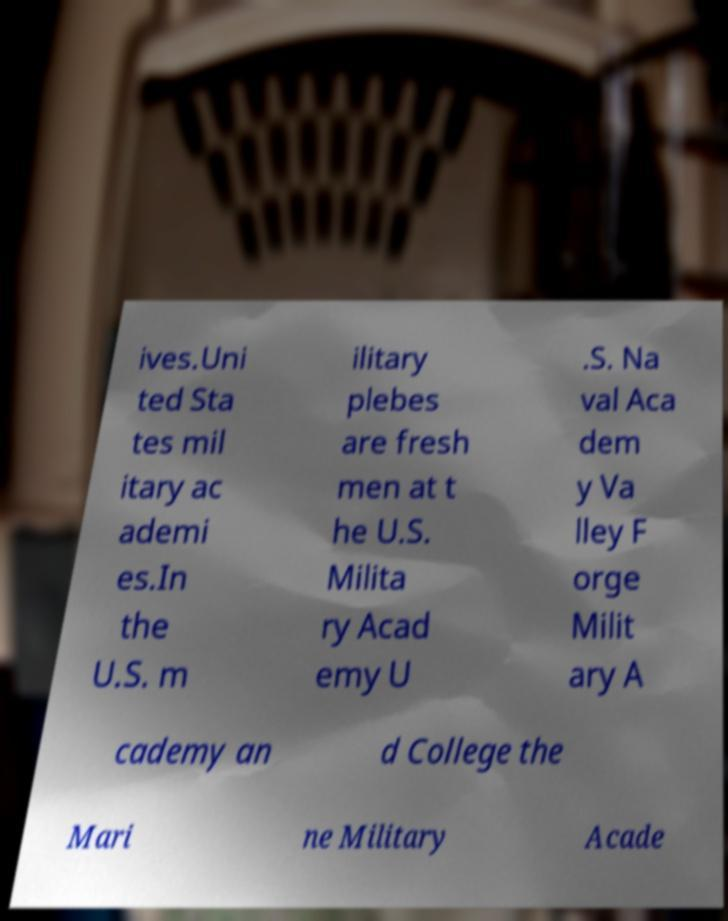Please identify and transcribe the text found in this image. ives.Uni ted Sta tes mil itary ac ademi es.In the U.S. m ilitary plebes are fresh men at t he U.S. Milita ry Acad emy U .S. Na val Aca dem y Va lley F orge Milit ary A cademy an d College the Mari ne Military Acade 